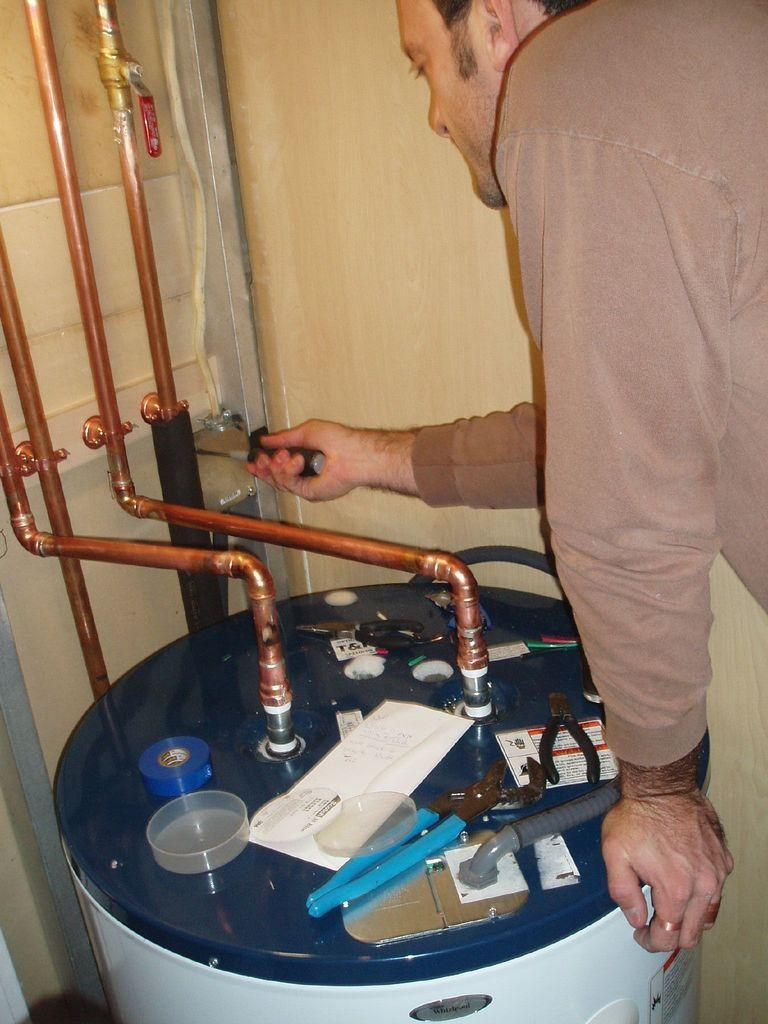What is one of the main features in the image? There is a wall in the image. What else can be seen in the image? There are pipes, a person on the right side, a machine, cutting pliers, a switch board, plaster, and paper on the machine. Can you describe the person in the image? The person is on the right side of the image, but no specific details about their appearance or actions are provided. What is the purpose of the machine in the image? The presence of cutting pliers, a switch board, plaster, and paper on the machine suggests that it may be used for construction or repair work. What type of food is being prepared in the image? There is no food present in the image. 